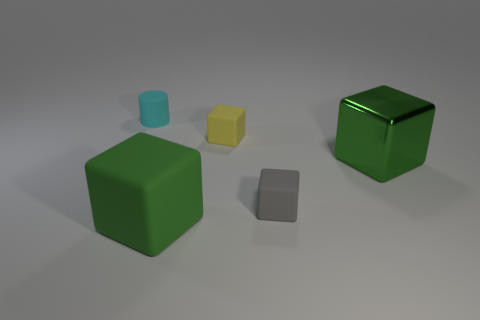Is there a brown rubber sphere of the same size as the yellow block?
Give a very brief answer. No. Is the number of green matte objects less than the number of big brown metallic balls?
Offer a very short reply. No. What is the shape of the big thing that is right of the green thing in front of the green cube right of the yellow matte cube?
Make the answer very short. Cube. What number of objects are things that are on the right side of the green rubber cube or objects in front of the cyan thing?
Give a very brief answer. 4. There is a large metal block; are there any blocks in front of it?
Keep it short and to the point. Yes. What number of things are objects in front of the tiny cyan rubber object or blue matte cylinders?
Provide a succinct answer. 4. What number of yellow objects are matte cubes or small rubber cubes?
Ensure brevity in your answer.  1. What number of other objects are there of the same color as the small cylinder?
Ensure brevity in your answer.  0. Is the number of yellow rubber blocks that are right of the gray rubber block less than the number of large cyan rubber spheres?
Offer a very short reply. No. There is a big object that is to the left of the big green object that is behind the green thing on the left side of the yellow matte block; what color is it?
Keep it short and to the point. Green. 